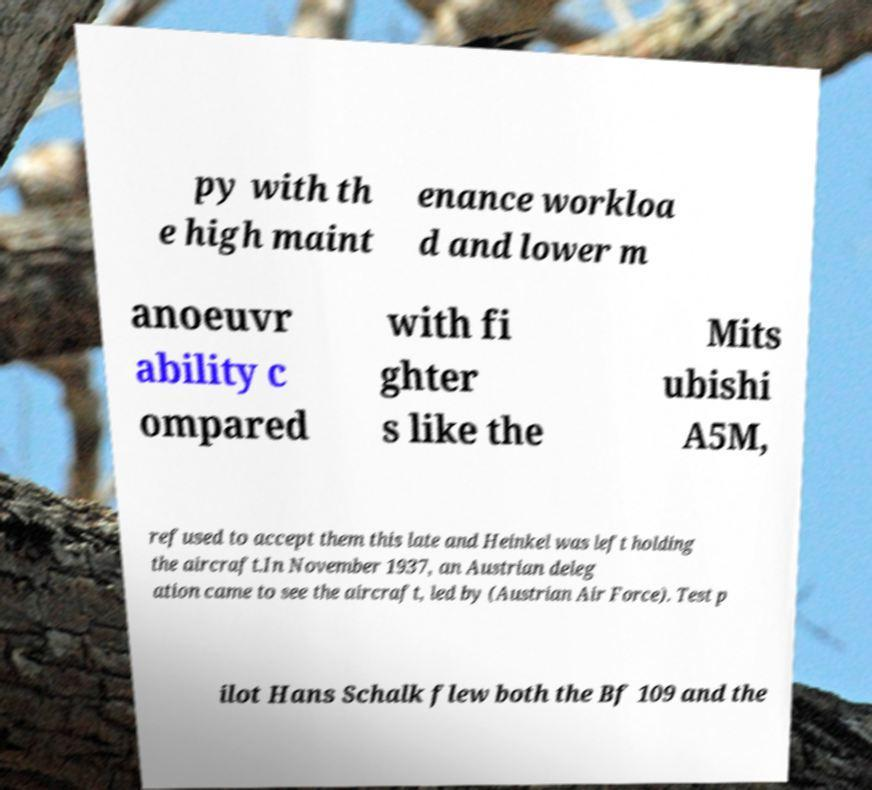Could you assist in decoding the text presented in this image and type it out clearly? py with th e high maint enance workloa d and lower m anoeuvr ability c ompared with fi ghter s like the Mits ubishi A5M, refused to accept them this late and Heinkel was left holding the aircraft.In November 1937, an Austrian deleg ation came to see the aircraft, led by (Austrian Air Force). Test p ilot Hans Schalk flew both the Bf 109 and the 